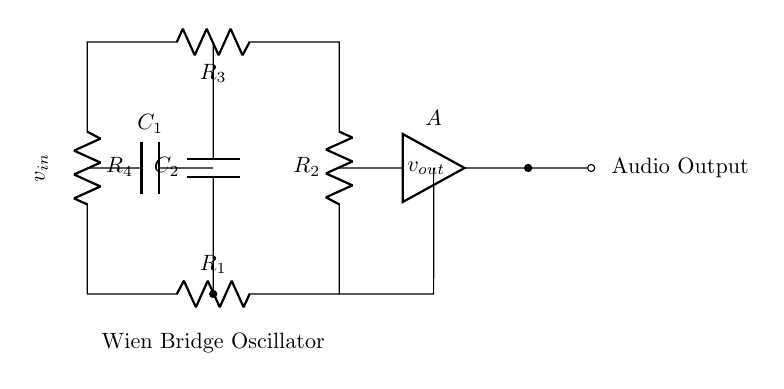What type of circuit is this? This circuit is a Wien Bridge Oscillator, which is a type of electronic oscillator that generates sine waves. Its structure includes resistors and capacitors arranged to determine the frequency of oscillation.
Answer: Wien Bridge Oscillator What are the components labeled in the circuit? The circuit includes four resistors (R1, R2, R3, R4), two capacitors (C1, C2), and an operational amplifier (A). Each component is indicated by its respective label in the diagram, making it clear what elements are present.
Answer: Resistors, capacitors, amplifier What is the purpose of the operational amplifier in this circuit? The purpose of the operational amplifier is to amplify the output signal generated by the Wien bridge oscillator. It is crucial for setting the gain and ensuring that the oscillation can sustain itself.
Answer: Amplification How many capacitors are used in this circuit? There are two capacitors, C1 and C2, connected in the circuit. Their function is to work with the resistors to set the frequency of the oscillation. The labels indicate their presence and importance in the oscillator's operation.
Answer: Two What does the 'v out' indicate? 'V out' indicates the output voltage of the oscillator, which represents the sine wave generated by the circuit. It is taken from the output of the operational amplifier, showing the signal that can be used in audio applications.
Answer: Output voltage What will happen if one of the resistors is removed? If one of the resistors is removed, it will disrupt the balance of the oscillator and can prevent it from oscillating correctly. The Wien bridge relies on the precise values and connections of resistors to function, so removing one may lead to a non-functional circuit.
Answer: Disruption of balance 